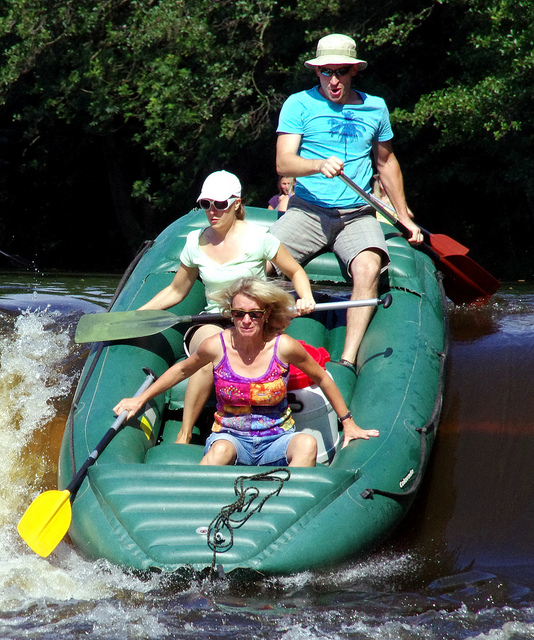What type of boat are they navigating the water on?
A. canoe
B. kayak
C. fishing
D. raft
Answer with the option's letter from the given choices directly. D 